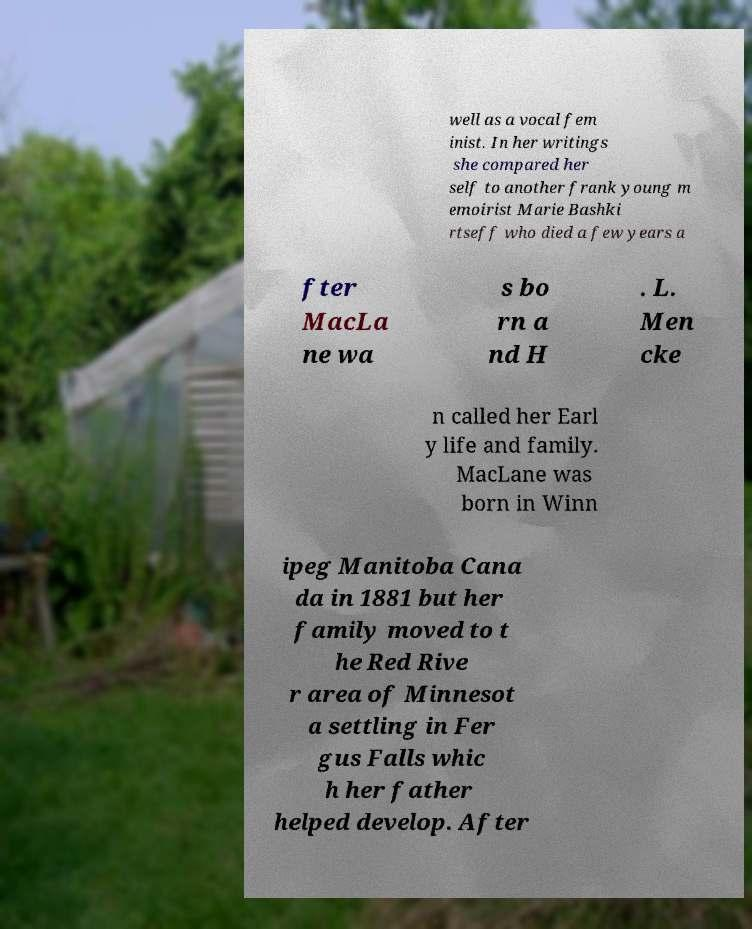Please identify and transcribe the text found in this image. well as a vocal fem inist. In her writings she compared her self to another frank young m emoirist Marie Bashki rtseff who died a few years a fter MacLa ne wa s bo rn a nd H . L. Men cke n called her Earl y life and family. MacLane was born in Winn ipeg Manitoba Cana da in 1881 but her family moved to t he Red Rive r area of Minnesot a settling in Fer gus Falls whic h her father helped develop. After 